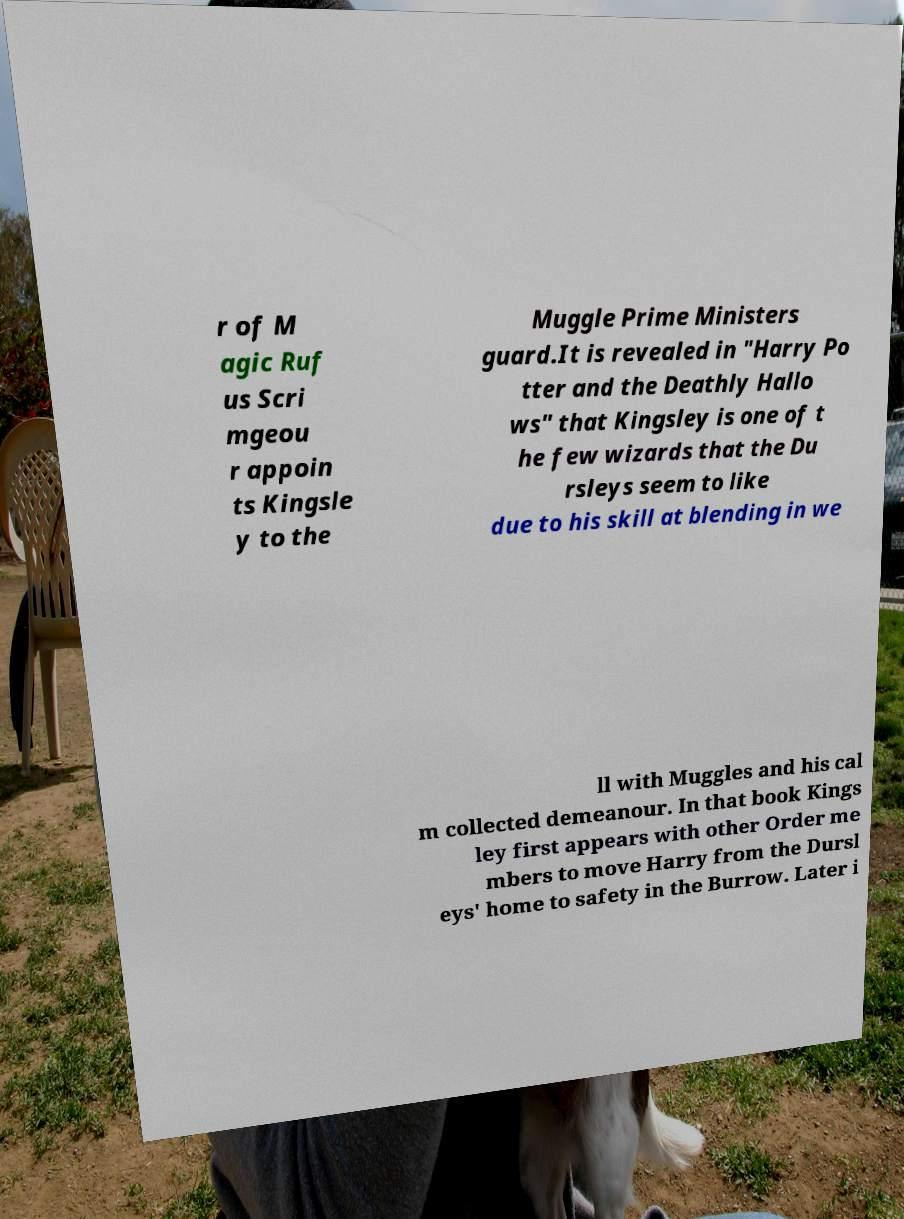I need the written content from this picture converted into text. Can you do that? r of M agic Ruf us Scri mgeou r appoin ts Kingsle y to the Muggle Prime Ministers guard.It is revealed in "Harry Po tter and the Deathly Hallo ws" that Kingsley is one of t he few wizards that the Du rsleys seem to like due to his skill at blending in we ll with Muggles and his cal m collected demeanour. In that book Kings ley first appears with other Order me mbers to move Harry from the Dursl eys' home to safety in the Burrow. Later i 